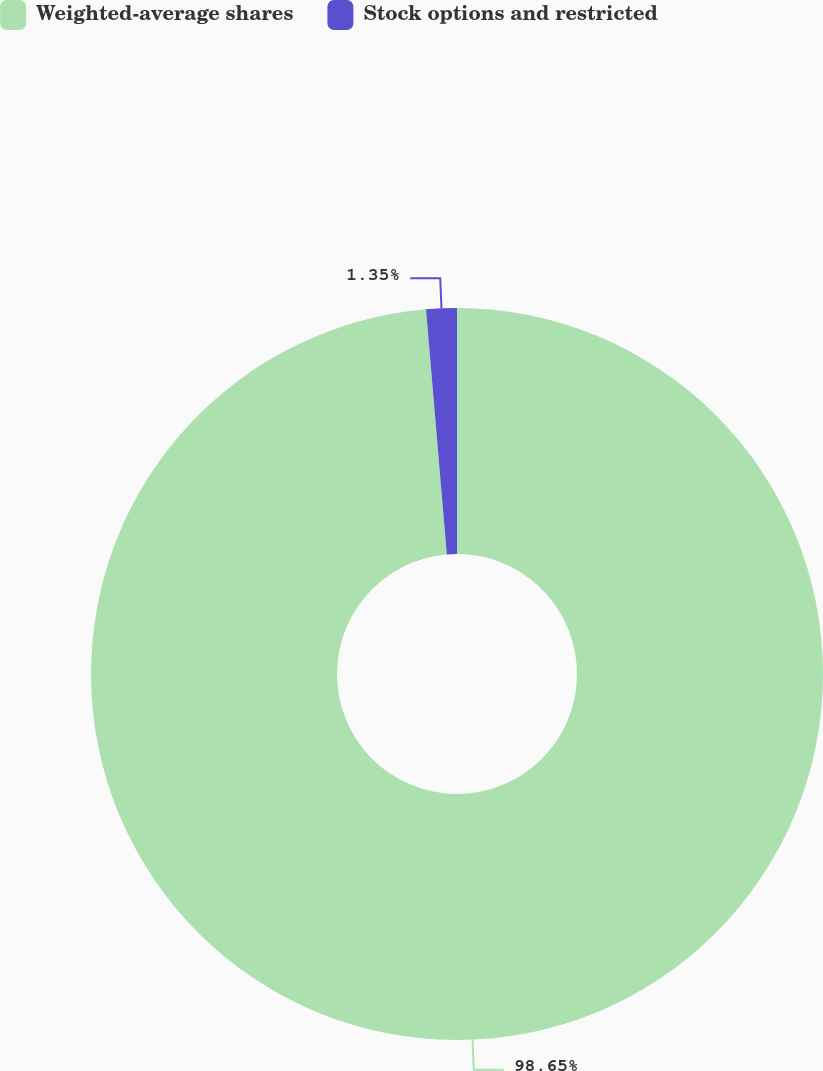<chart> <loc_0><loc_0><loc_500><loc_500><pie_chart><fcel>Weighted-average shares<fcel>Stock options and restricted<nl><fcel>98.65%<fcel>1.35%<nl></chart> 